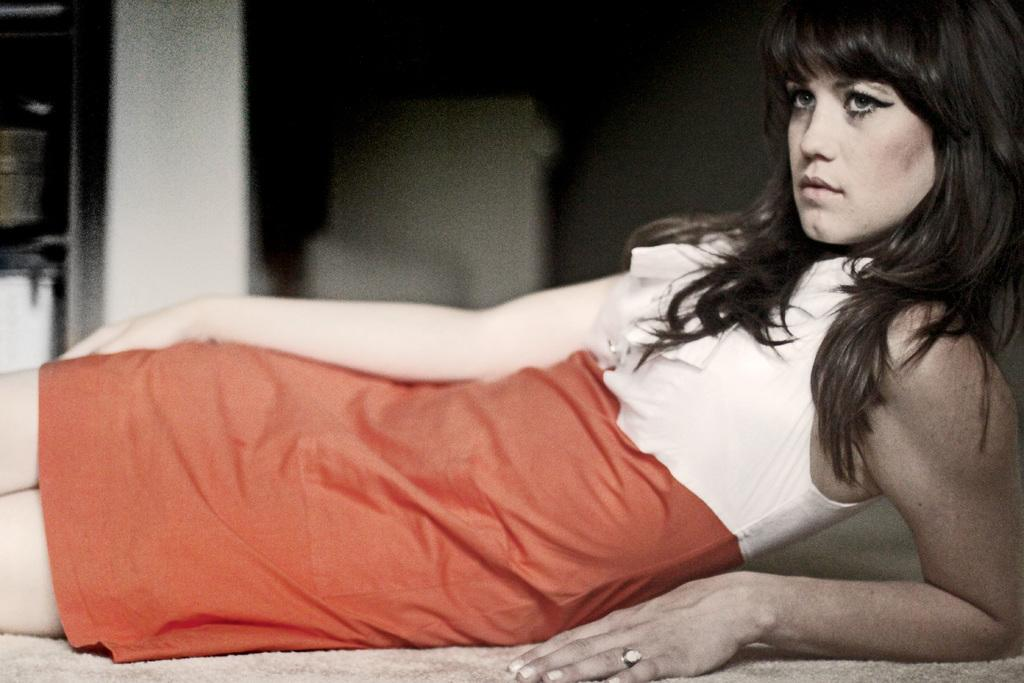What is the main subject of the image? There is a woman in the image. What is the woman wearing on her upper body? The woman is wearing a white shirt. What is the woman wearing on her lower body? The woman is wearing an orange skirt. How many feathers can be seen on the woman's skirt in the image? There are no feathers present on the woman's skirt in the image. What is the woman doing in the image? The provided facts do not mention any specific action or activity the woman is performing in the image. 